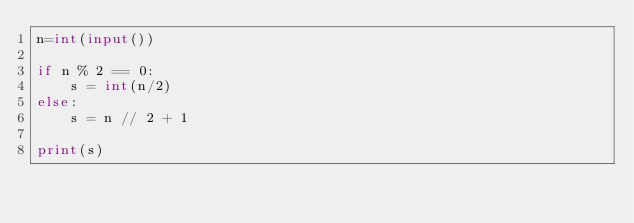Convert code to text. <code><loc_0><loc_0><loc_500><loc_500><_Python_>n=int(input())

if n % 2 == 0:
    s = int(n/2)
else:
    s = n // 2 + 1

print(s)
</code> 